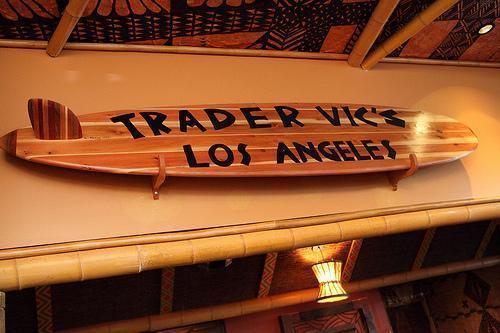How many signs are there?
Give a very brief answer. 1. 